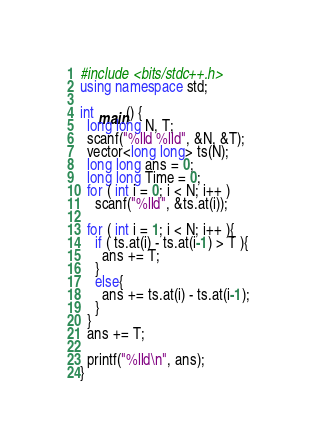Convert code to text. <code><loc_0><loc_0><loc_500><loc_500><_C++_>#include <bits/stdc++.h>
using namespace std;

int main() {
  long long N, T;
  scanf("%lld %lld", &N, &T);
  vector<long long> ts(N);
  long long ans = 0;
  long long Time = 0;
  for ( int i = 0; i < N; i++ )
    scanf("%lld", &ts.at(i));
  
  for ( int i = 1; i < N; i++ ){
    if ( ts.at(i) - ts.at(i-1) > T ){
      ans += T;
    }
    else{
      ans += ts.at(i) - ts.at(i-1);
    }
  }
  ans += T;

  printf("%lld\n", ans);
}</code> 